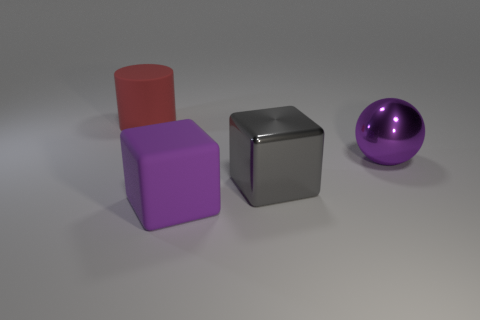Add 1 big purple matte blocks. How many objects exist? 5 Subtract all purple cubes. How many cubes are left? 1 Subtract all cylinders. How many objects are left? 3 Subtract 1 cylinders. How many cylinders are left? 0 Subtract all brown balls. Subtract all blue cubes. How many balls are left? 1 Subtract all yellow spheres. How many gray cubes are left? 1 Subtract all large red matte cylinders. Subtract all large red rubber objects. How many objects are left? 2 Add 2 purple metallic objects. How many purple metallic objects are left? 3 Add 3 large gray shiny blocks. How many large gray shiny blocks exist? 4 Subtract 0 red blocks. How many objects are left? 4 